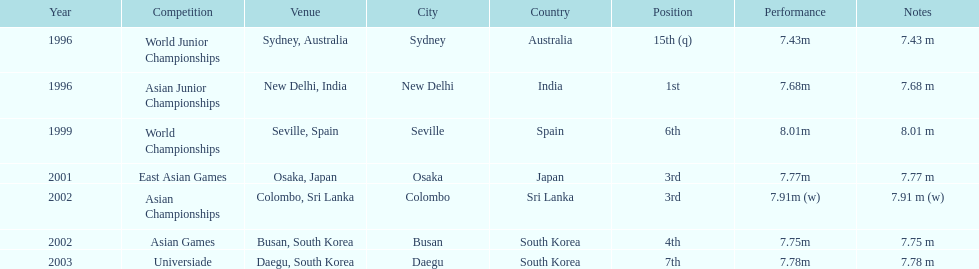In what year was the position of 3rd first achieved? 2001. 